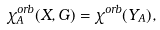<formula> <loc_0><loc_0><loc_500><loc_500>\chi ^ { o r b } _ { A } ( X , G ) = \chi ^ { o r b } ( Y _ { A } ) ,</formula> 